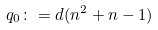Convert formula to latex. <formula><loc_0><loc_0><loc_500><loc_500>q _ { 0 } \colon = d ( n ^ { 2 } + n - 1 )</formula> 